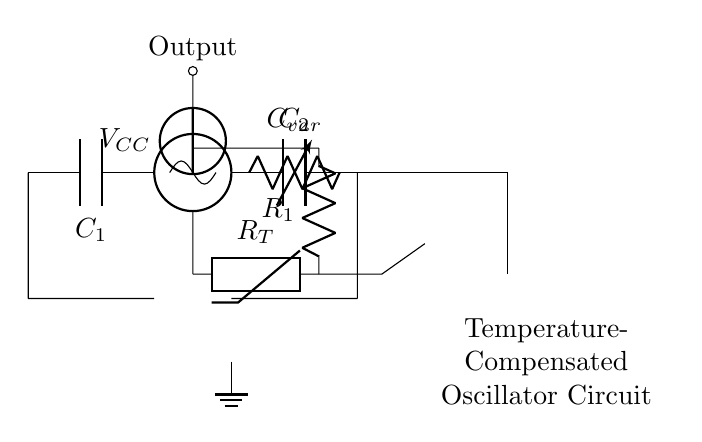What component is used for frequency adjustment? The component used for frequency adjustment in this circuit is the varactor diode, indicated as C_var. Varactor diodes can adjust their capacitance based on the reverse voltage applied, allowing for fine-tuning of the oscillator's frequency.
Answer: Varactor diode What is the purpose of the thermistor in this circuit? The thermistor, labeled as R_T, is used for temperature sensing and compensation. It changes its resistance with temperature, which affects the feedback to stabilize the oscillator frequency against temperature changes, ensuring stability in varying environments.
Answer: Temperature compensation What is the total number of capacitors in the circuit? There are two capacitors in the circuit, labeled as C_1 and C_2. Capacitors are used to filter noise and maintain frequency stability in oscillators, contributing to the overall performance of the circuit.
Answer: Two Which direction does the current flow from the voltage source? The current from the voltage source, labeled as V_CC, flows towards the north, which connects to the oscillator input. Following the connections in the circuit shows that current flows from the positive terminal of the voltage source to the oscillator.
Answer: North How does the operational amplifier contribute to the circuit's function? The operational amplifier, connected from the thermistor to the varactor diode, serves to amplify the signal related to temperature changes. It processes the voltage from the thermistor and adjusts the control voltage for the varactor diode, thus compensating for frequency drift due to temperature variations.
Answer: Signal amplification What is the labeling of the output node in the circuit? The output node of the circuit is labeled as "Output" above the oscillator symbol. This indicates the point from which the frequency signal is taken for further processing or transmission.
Answer: Output What is the role of capacitor C_2 in the oscillator circuit? Capacitor C_2 is used for stability and filtering in the oscillator circuit. It helps eliminate unwanted noise and stabilizes the oscillation frequency, ensuring the oscillator operates reliably under varying conditions.
Answer: Stability and filtering 